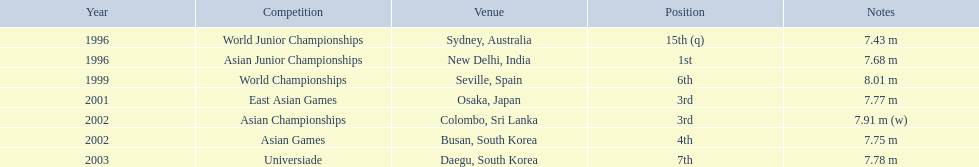In which contest did huang le secure 3rd position? East Asian Games. In which contest did he secure 4th position? Asian Games. When did he attain 1st position? Asian Junior Championships. 